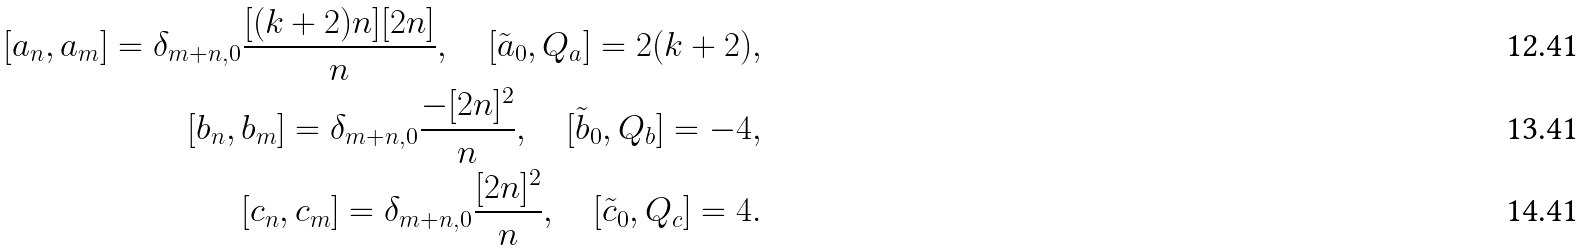Convert formula to latex. <formula><loc_0><loc_0><loc_500><loc_500>[ a _ { n } , a _ { m } ] = \delta _ { m + n , 0 } \frac { [ ( k + 2 ) n ] [ 2 n ] } { n } , \quad [ \tilde { a } _ { 0 } , Q _ { a } ] = 2 ( k + 2 ) , \\ [ b _ { n } , b _ { m } ] = \delta _ { m + n , 0 } \frac { - [ 2 n ] ^ { 2 } } { n } , \quad [ \tilde { b } _ { 0 } , Q _ { b } ] = - 4 , \\ [ c _ { n } , c _ { m } ] = \delta _ { m + n , 0 } \frac { [ 2 n ] ^ { 2 } } { n } , \quad [ \tilde { c } _ { 0 } , Q _ { c } ] = 4 .</formula> 